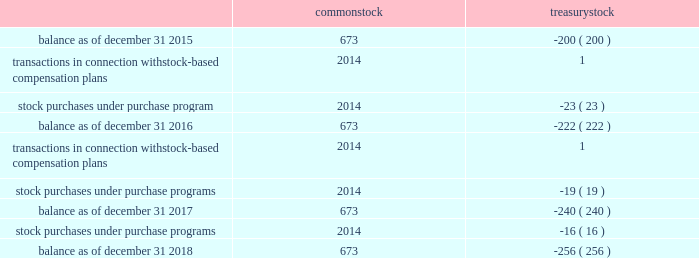Table of contents valero energy corporation notes to consolidated financial statements ( continued ) 11 .
Equity share activity activity in the number of shares of common stock and treasury stock was as follows ( in millions ) : common treasury .
Preferred stock we have 20 million shares of preferred stock authorized with a par value of $ 0.01 per share .
No shares of preferred stock were outstanding as of december 31 , 2018 or 2017 .
Treasury stock we purchase shares of our common stock as authorized under our common stock purchase program ( described below ) and to meet our obligations under employee stock-based compensation plans .
On july 13 , 2015 , our board of directors authorized us to purchase $ 2.5 billion of our outstanding common stock with no expiration date , and we completed that program during 2017 .
On september 21 , 2016 , our board of directors authorized our purchase of up to an additional $ 2.5 billion with no expiration date , and we completed that program during 2018 .
On january 23 , 2018 , our board of directors authorized our purchase of up to an additional $ 2.5 billion ( the 2018 program ) with no expiration date .
During the years ended december 31 , 2018 , 2017 , and 2016 , we purchased $ 1.5 billion , $ 1.3 billion , and $ 1.3 billion , respectively , of our common stock under our programs .
As of december 31 , 2018 , we have approval under the 2018 program to purchase approximately $ 2.2 billion of our common stock .
Common stock dividends on january 24 , 2019 , our board of directors declared a quarterly cash dividend of $ 0.90 per common share payable on march 5 , 2019 to holders of record at the close of business on february 13 , 2019 .
Valero energy partners lp units on september 16 , 2016 , vlp entered into an equity distribution agreement pursuant to which vlp offered and sold from time to time their common units having an aggregate offering price of up to $ 350 million based on amounts , at prices , and on terms determined by market conditions and other factors at the time of .
How much , in billions , was spent purchasing common stock under the programs from 2016-2018? 
Computations: ((1.5 + 1.3) + 1.3)
Answer: 4.1. 